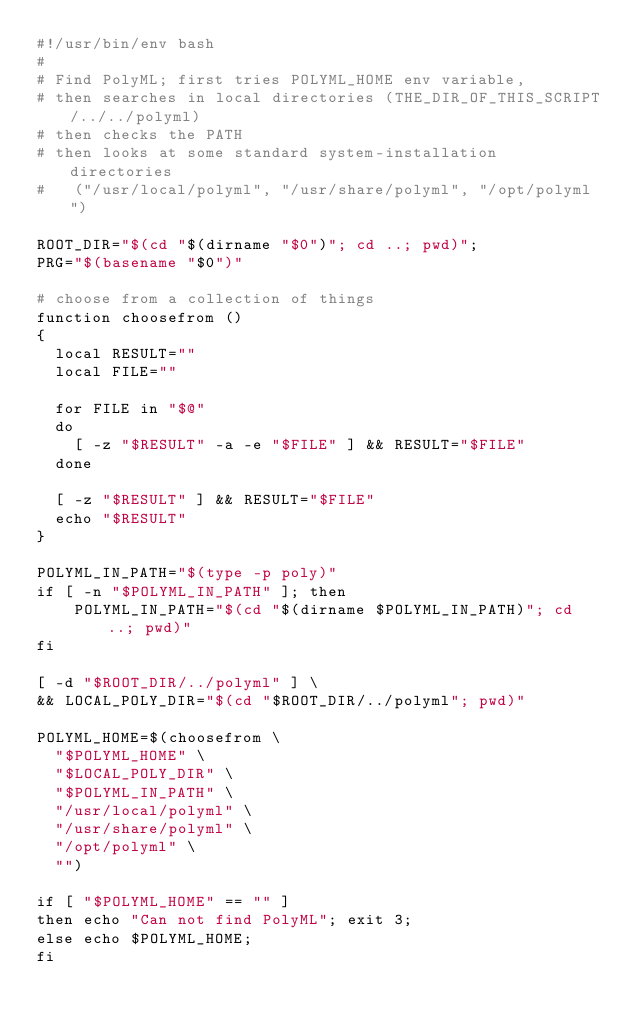Convert code to text. <code><loc_0><loc_0><loc_500><loc_500><_Bash_>#!/usr/bin/env bash
#
# Find PolyML; first tries POLYML_HOME env variable, 
# then searches in local directories (THE_DIR_OF_THIS_SCRIPT/../../polyml)
# then checks the PATH
# then looks at some standard system-installation directories 
#   ("/usr/local/polyml", "/usr/share/polyml", "/opt/polyml")

ROOT_DIR="$(cd "$(dirname "$0")"; cd ..; pwd)";
PRG="$(basename "$0")"

# choose from a collection of things
function choosefrom ()
{
  local RESULT=""
  local FILE=""

  for FILE in "$@"
  do
    [ -z "$RESULT" -a -e "$FILE" ] && RESULT="$FILE"
  done

  [ -z "$RESULT" ] && RESULT="$FILE"
  echo "$RESULT"
}

POLYML_IN_PATH="$(type -p poly)"
if [ -n "$POLYML_IN_PATH" ]; then 
    POLYML_IN_PATH="$(cd "$(dirname $POLYML_IN_PATH)"; cd ..; pwd)"
fi

[ -d "$ROOT_DIR/../polyml" ] \
&& LOCAL_POLY_DIR="$(cd "$ROOT_DIR/../polyml"; pwd)"

POLYML_HOME=$(choosefrom \
  "$POLYML_HOME" \
  "$LOCAL_POLY_DIR" \
  "$POLYML_IN_PATH" \
  "/usr/local/polyml" \
  "/usr/share/polyml" \
  "/opt/polyml" \
  "")

if [ "$POLYML_HOME" == "" ]
then echo "Can not find PolyML"; exit 3; 
else echo $POLYML_HOME;
fi</code> 